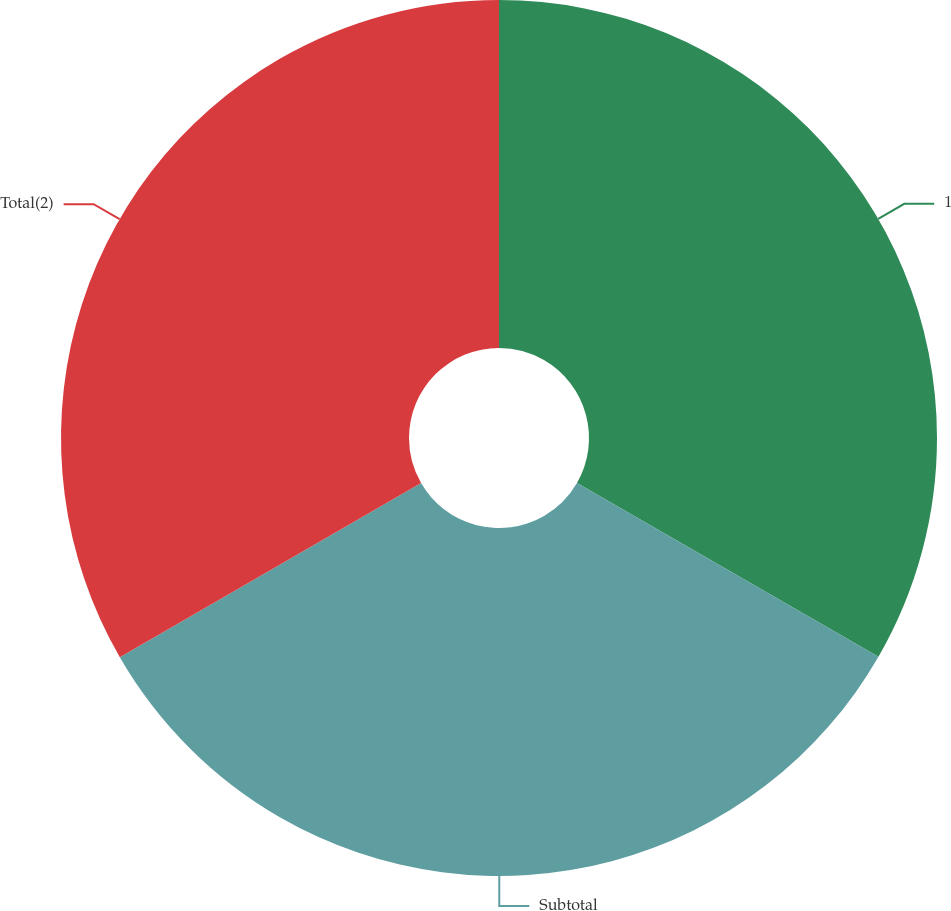<chart> <loc_0><loc_0><loc_500><loc_500><pie_chart><fcel>1<fcel>Subtotal<fcel>Total(2)<nl><fcel>33.32%<fcel>33.33%<fcel>33.34%<nl></chart> 